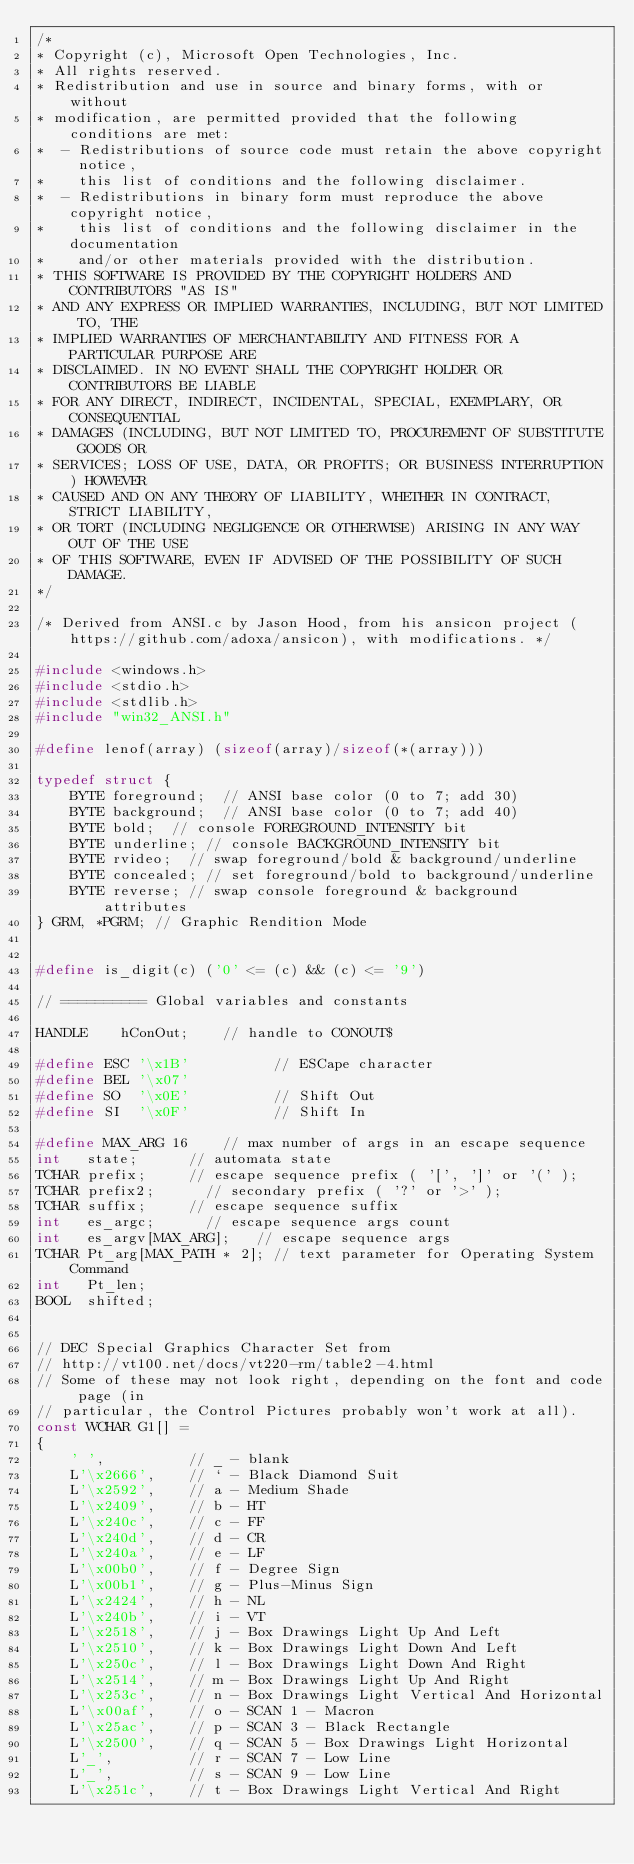Convert code to text. <code><loc_0><loc_0><loc_500><loc_500><_C_>/*
* Copyright (c), Microsoft Open Technologies, Inc.
* All rights reserved.
* Redistribution and use in source and binary forms, with or without
* modification, are permitted provided that the following conditions are met:
*  - Redistributions of source code must retain the above copyright notice,
*    this list of conditions and the following disclaimer.
*  - Redistributions in binary form must reproduce the above copyright notice,
*    this list of conditions and the following disclaimer in the documentation
*    and/or other materials provided with the distribution.
* THIS SOFTWARE IS PROVIDED BY THE COPYRIGHT HOLDERS AND CONTRIBUTORS "AS IS"
* AND ANY EXPRESS OR IMPLIED WARRANTIES, INCLUDING, BUT NOT LIMITED TO, THE
* IMPLIED WARRANTIES OF MERCHANTABILITY AND FITNESS FOR A PARTICULAR PURPOSE ARE
* DISCLAIMED. IN NO EVENT SHALL THE COPYRIGHT HOLDER OR CONTRIBUTORS BE LIABLE
* FOR ANY DIRECT, INDIRECT, INCIDENTAL, SPECIAL, EXEMPLARY, OR CONSEQUENTIAL
* DAMAGES (INCLUDING, BUT NOT LIMITED TO, PROCUREMENT OF SUBSTITUTE GOODS OR
* SERVICES; LOSS OF USE, DATA, OR PROFITS; OR BUSINESS INTERRUPTION) HOWEVER
* CAUSED AND ON ANY THEORY OF LIABILITY, WHETHER IN CONTRACT, STRICT LIABILITY,
* OR TORT (INCLUDING NEGLIGENCE OR OTHERWISE) ARISING IN ANY WAY OUT OF THE USE
* OF THIS SOFTWARE, EVEN IF ADVISED OF THE POSSIBILITY OF SUCH DAMAGE.
*/

/* Derived from ANSI.c by Jason Hood, from his ansicon project (https://github.com/adoxa/ansicon), with modifications. */

#include <windows.h>
#include <stdio.h>
#include <stdlib.h>
#include "win32_ANSI.h"

#define lenof(array) (sizeof(array)/sizeof(*(array)))

typedef struct {
    BYTE foreground;	// ANSI base color (0 to 7; add 30)
    BYTE background;	// ANSI base color (0 to 7; add 40)
    BYTE bold;	// console FOREGROUND_INTENSITY bit
    BYTE underline;	// console BACKGROUND_INTENSITY bit
    BYTE rvideo;	// swap foreground/bold & background/underline
    BYTE concealed;	// set foreground/bold to background/underline
    BYTE reverse; // swap console foreground & background attributes
} GRM, *PGRM;	// Graphic Rendition Mode


#define is_digit(c) ('0' <= (c) && (c) <= '9')

// ========== Global variables and constants

HANDLE	  hConOut;		// handle to CONOUT$

#define ESC	'\x1B'          // ESCape character
#define BEL	'\x07'
#define SO	'\x0E'          // Shift Out
#define SI	'\x0F'          // Shift In

#define MAX_ARG 16		// max number of args in an escape sequence
int   state;			// automata state
TCHAR prefix;			// escape sequence prefix ( '[', ']' or '(' );
TCHAR prefix2;			// secondary prefix ( '?' or '>' );
TCHAR suffix;			// escape sequence suffix
int   es_argc;			// escape sequence args count
int   es_argv[MAX_ARG]; 	// escape sequence args
TCHAR Pt_arg[MAX_PATH * 2];	// text parameter for Operating System Command
int   Pt_len;
BOOL  shifted;


// DEC Special Graphics Character Set from
// http://vt100.net/docs/vt220-rm/table2-4.html
// Some of these may not look right, depending on the font and code page (in
// particular, the Control Pictures probably won't work at all).
const WCHAR G1[] =
{
    ' ',          // _ - blank
    L'\x2666',    // ` - Black Diamond Suit
    L'\x2592',    // a - Medium Shade
    L'\x2409',    // b - HT
    L'\x240c',    // c - FF
    L'\x240d',    // d - CR
    L'\x240a',    // e - LF
    L'\x00b0',    // f - Degree Sign
    L'\x00b1',    // g - Plus-Minus Sign
    L'\x2424',    // h - NL
    L'\x240b',    // i - VT
    L'\x2518',    // j - Box Drawings Light Up And Left
    L'\x2510',    // k - Box Drawings Light Down And Left
    L'\x250c',    // l - Box Drawings Light Down And Right
    L'\x2514',    // m - Box Drawings Light Up And Right
    L'\x253c',    // n - Box Drawings Light Vertical And Horizontal
    L'\x00af',    // o - SCAN 1 - Macron
    L'\x25ac',    // p - SCAN 3 - Black Rectangle
    L'\x2500',    // q - SCAN 5 - Box Drawings Light Horizontal
    L'_',         // r - SCAN 7 - Low Line
    L'_',         // s - SCAN 9 - Low Line
    L'\x251c',    // t - Box Drawings Light Vertical And Right</code> 